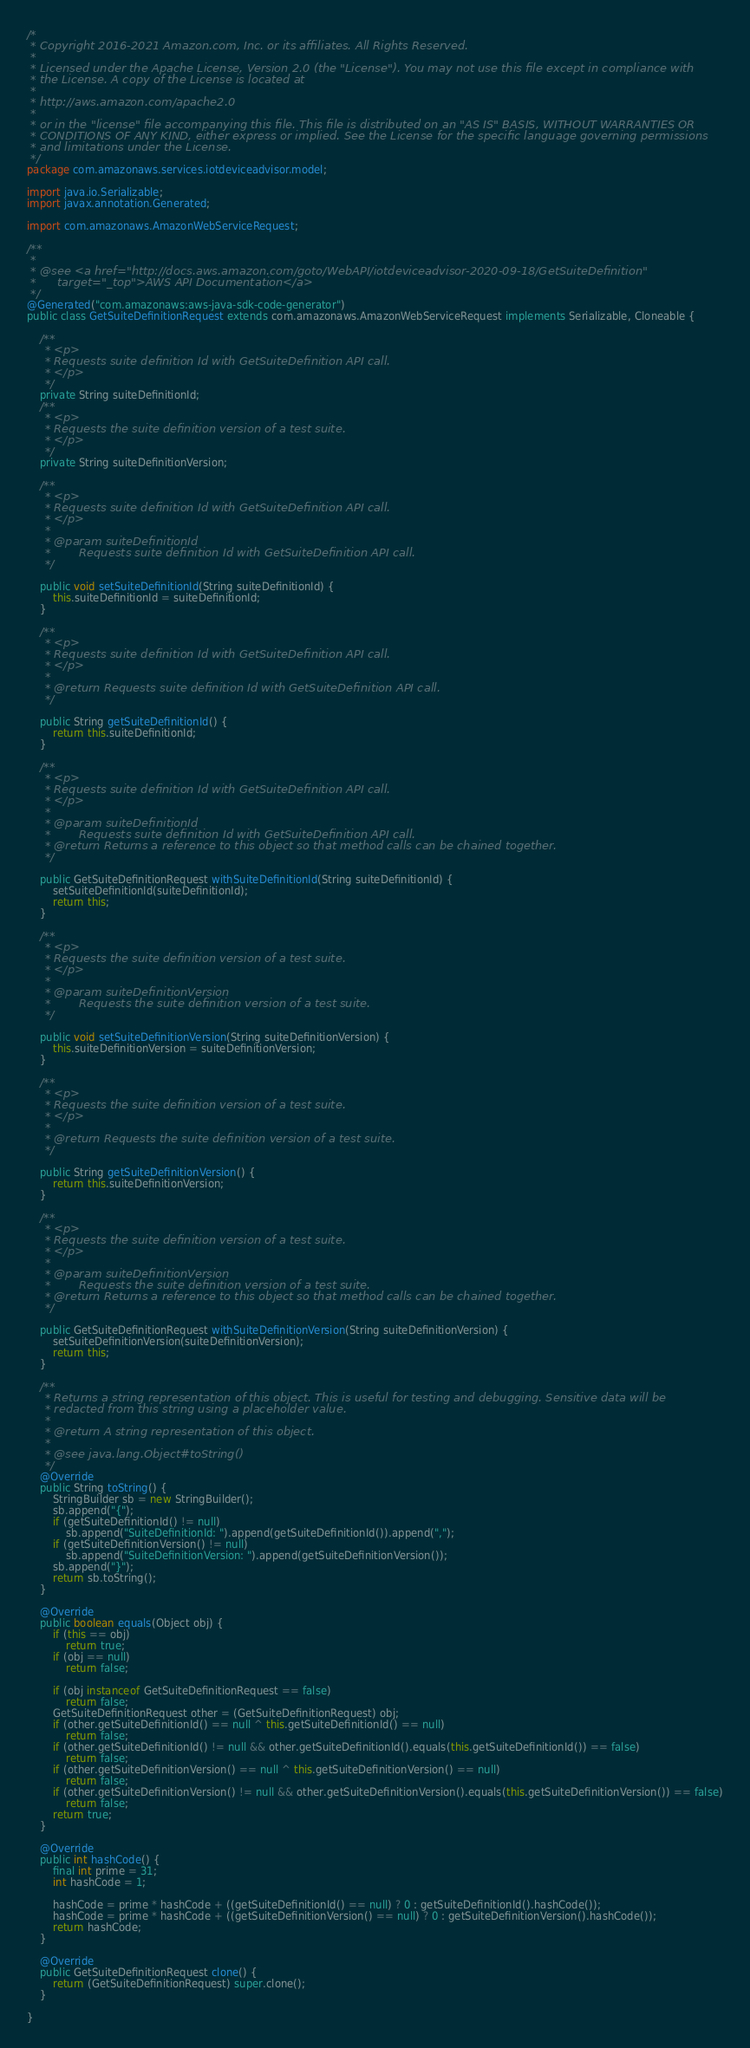<code> <loc_0><loc_0><loc_500><loc_500><_Java_>/*
 * Copyright 2016-2021 Amazon.com, Inc. or its affiliates. All Rights Reserved.
 * 
 * Licensed under the Apache License, Version 2.0 (the "License"). You may not use this file except in compliance with
 * the License. A copy of the License is located at
 * 
 * http://aws.amazon.com/apache2.0
 * 
 * or in the "license" file accompanying this file. This file is distributed on an "AS IS" BASIS, WITHOUT WARRANTIES OR
 * CONDITIONS OF ANY KIND, either express or implied. See the License for the specific language governing permissions
 * and limitations under the License.
 */
package com.amazonaws.services.iotdeviceadvisor.model;

import java.io.Serializable;
import javax.annotation.Generated;

import com.amazonaws.AmazonWebServiceRequest;

/**
 * 
 * @see <a href="http://docs.aws.amazon.com/goto/WebAPI/iotdeviceadvisor-2020-09-18/GetSuiteDefinition"
 *      target="_top">AWS API Documentation</a>
 */
@Generated("com.amazonaws:aws-java-sdk-code-generator")
public class GetSuiteDefinitionRequest extends com.amazonaws.AmazonWebServiceRequest implements Serializable, Cloneable {

    /**
     * <p>
     * Requests suite definition Id with GetSuiteDefinition API call.
     * </p>
     */
    private String suiteDefinitionId;
    /**
     * <p>
     * Requests the suite definition version of a test suite.
     * </p>
     */
    private String suiteDefinitionVersion;

    /**
     * <p>
     * Requests suite definition Id with GetSuiteDefinition API call.
     * </p>
     * 
     * @param suiteDefinitionId
     *        Requests suite definition Id with GetSuiteDefinition API call.
     */

    public void setSuiteDefinitionId(String suiteDefinitionId) {
        this.suiteDefinitionId = suiteDefinitionId;
    }

    /**
     * <p>
     * Requests suite definition Id with GetSuiteDefinition API call.
     * </p>
     * 
     * @return Requests suite definition Id with GetSuiteDefinition API call.
     */

    public String getSuiteDefinitionId() {
        return this.suiteDefinitionId;
    }

    /**
     * <p>
     * Requests suite definition Id with GetSuiteDefinition API call.
     * </p>
     * 
     * @param suiteDefinitionId
     *        Requests suite definition Id with GetSuiteDefinition API call.
     * @return Returns a reference to this object so that method calls can be chained together.
     */

    public GetSuiteDefinitionRequest withSuiteDefinitionId(String suiteDefinitionId) {
        setSuiteDefinitionId(suiteDefinitionId);
        return this;
    }

    /**
     * <p>
     * Requests the suite definition version of a test suite.
     * </p>
     * 
     * @param suiteDefinitionVersion
     *        Requests the suite definition version of a test suite.
     */

    public void setSuiteDefinitionVersion(String suiteDefinitionVersion) {
        this.suiteDefinitionVersion = suiteDefinitionVersion;
    }

    /**
     * <p>
     * Requests the suite definition version of a test suite.
     * </p>
     * 
     * @return Requests the suite definition version of a test suite.
     */

    public String getSuiteDefinitionVersion() {
        return this.suiteDefinitionVersion;
    }

    /**
     * <p>
     * Requests the suite definition version of a test suite.
     * </p>
     * 
     * @param suiteDefinitionVersion
     *        Requests the suite definition version of a test suite.
     * @return Returns a reference to this object so that method calls can be chained together.
     */

    public GetSuiteDefinitionRequest withSuiteDefinitionVersion(String suiteDefinitionVersion) {
        setSuiteDefinitionVersion(suiteDefinitionVersion);
        return this;
    }

    /**
     * Returns a string representation of this object. This is useful for testing and debugging. Sensitive data will be
     * redacted from this string using a placeholder value.
     *
     * @return A string representation of this object.
     *
     * @see java.lang.Object#toString()
     */
    @Override
    public String toString() {
        StringBuilder sb = new StringBuilder();
        sb.append("{");
        if (getSuiteDefinitionId() != null)
            sb.append("SuiteDefinitionId: ").append(getSuiteDefinitionId()).append(",");
        if (getSuiteDefinitionVersion() != null)
            sb.append("SuiteDefinitionVersion: ").append(getSuiteDefinitionVersion());
        sb.append("}");
        return sb.toString();
    }

    @Override
    public boolean equals(Object obj) {
        if (this == obj)
            return true;
        if (obj == null)
            return false;

        if (obj instanceof GetSuiteDefinitionRequest == false)
            return false;
        GetSuiteDefinitionRequest other = (GetSuiteDefinitionRequest) obj;
        if (other.getSuiteDefinitionId() == null ^ this.getSuiteDefinitionId() == null)
            return false;
        if (other.getSuiteDefinitionId() != null && other.getSuiteDefinitionId().equals(this.getSuiteDefinitionId()) == false)
            return false;
        if (other.getSuiteDefinitionVersion() == null ^ this.getSuiteDefinitionVersion() == null)
            return false;
        if (other.getSuiteDefinitionVersion() != null && other.getSuiteDefinitionVersion().equals(this.getSuiteDefinitionVersion()) == false)
            return false;
        return true;
    }

    @Override
    public int hashCode() {
        final int prime = 31;
        int hashCode = 1;

        hashCode = prime * hashCode + ((getSuiteDefinitionId() == null) ? 0 : getSuiteDefinitionId().hashCode());
        hashCode = prime * hashCode + ((getSuiteDefinitionVersion() == null) ? 0 : getSuiteDefinitionVersion().hashCode());
        return hashCode;
    }

    @Override
    public GetSuiteDefinitionRequest clone() {
        return (GetSuiteDefinitionRequest) super.clone();
    }

}
</code> 